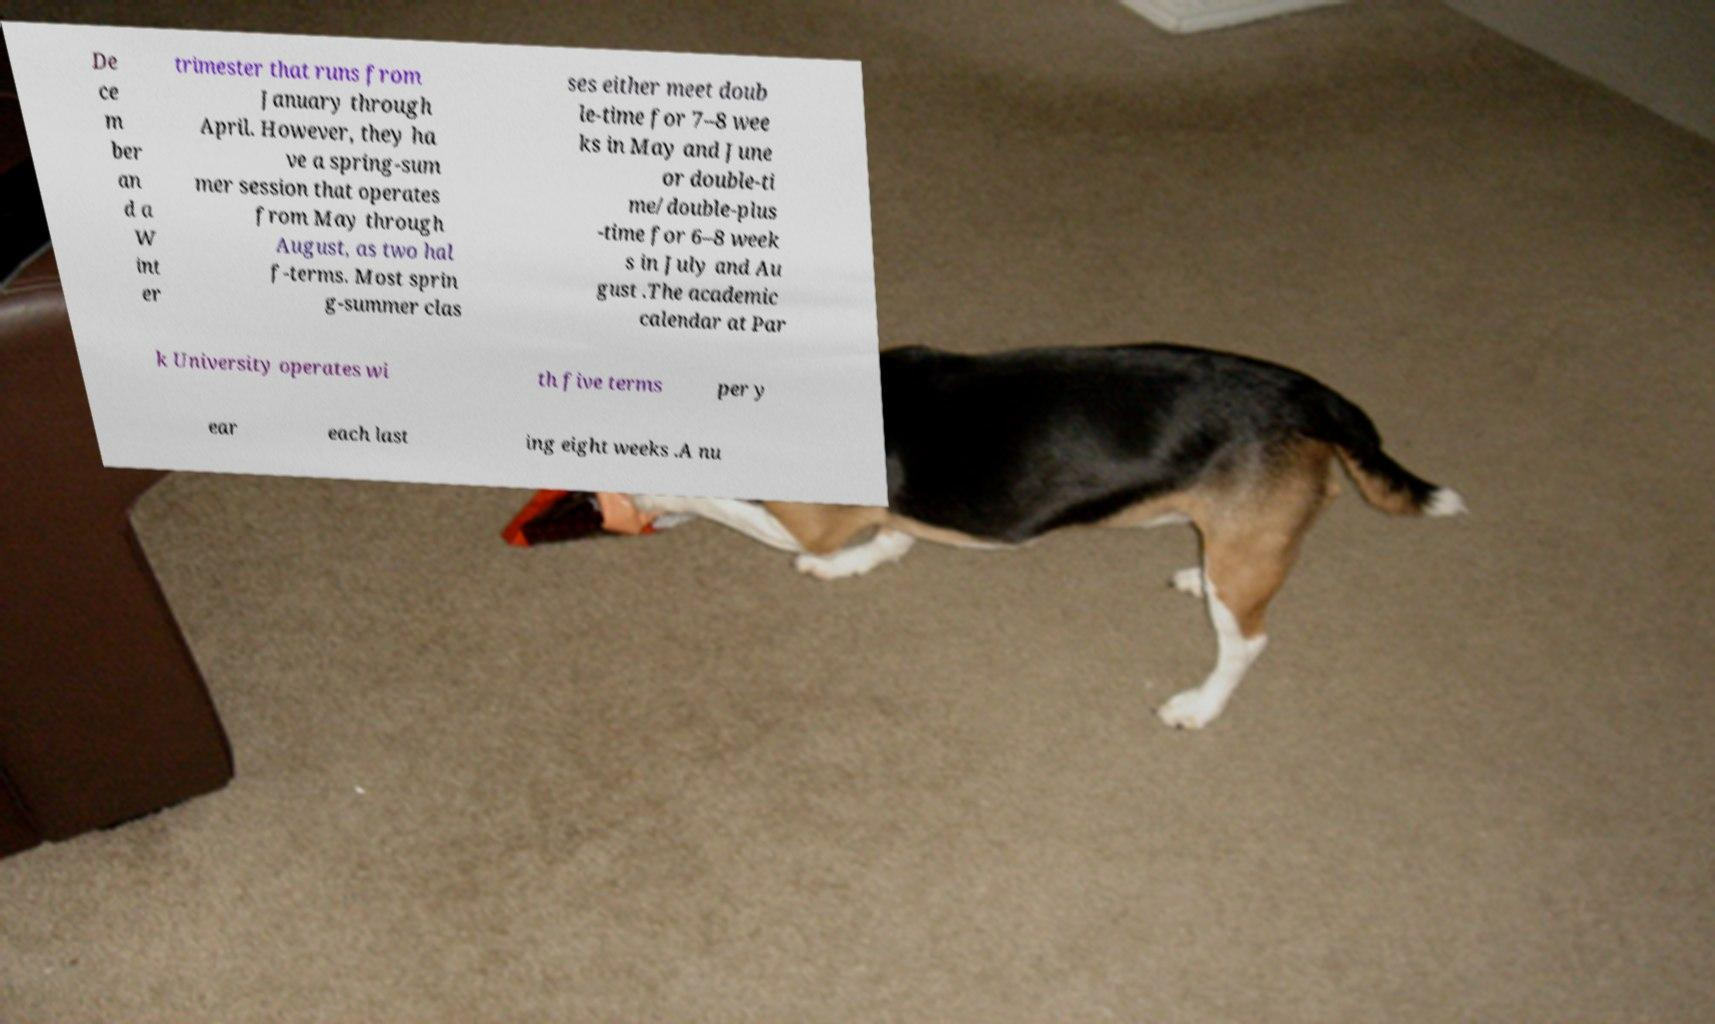Could you extract and type out the text from this image? De ce m ber an d a W int er trimester that runs from January through April. However, they ha ve a spring-sum mer session that operates from May through August, as two hal f-terms. Most sprin g-summer clas ses either meet doub le-time for 7–8 wee ks in May and June or double-ti me/double-plus -time for 6–8 week s in July and Au gust .The academic calendar at Par k University operates wi th five terms per y ear each last ing eight weeks .A nu 